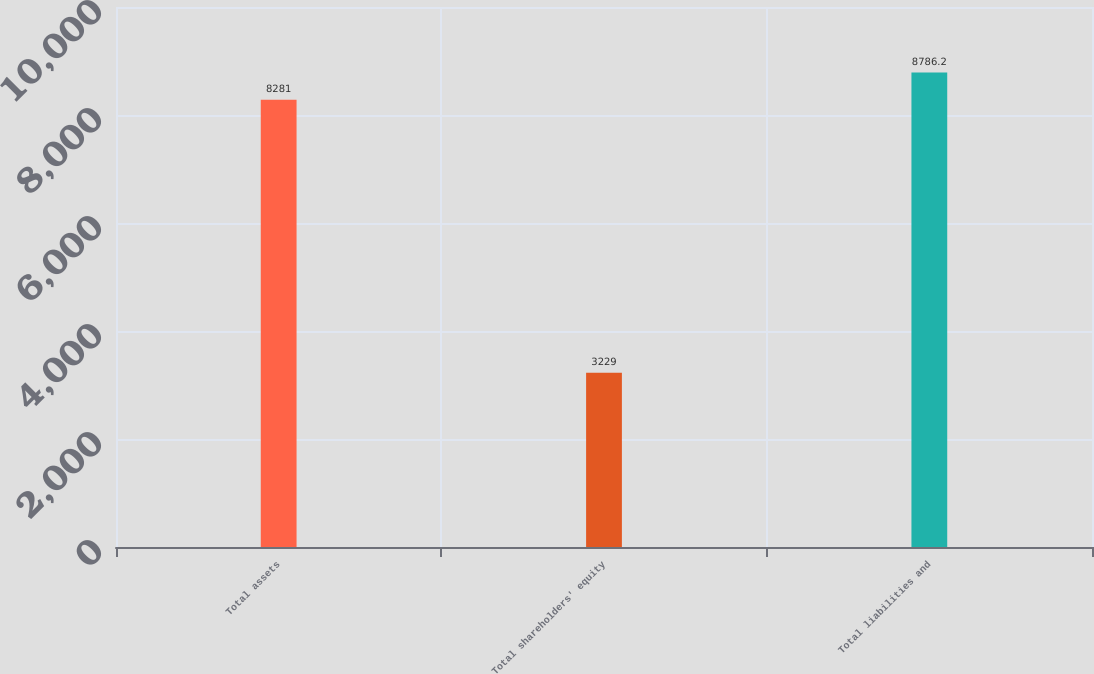Convert chart to OTSL. <chart><loc_0><loc_0><loc_500><loc_500><bar_chart><fcel>Total assets<fcel>Total shareholders' equity<fcel>Total liabilities and<nl><fcel>8281<fcel>3229<fcel>8786.2<nl></chart> 